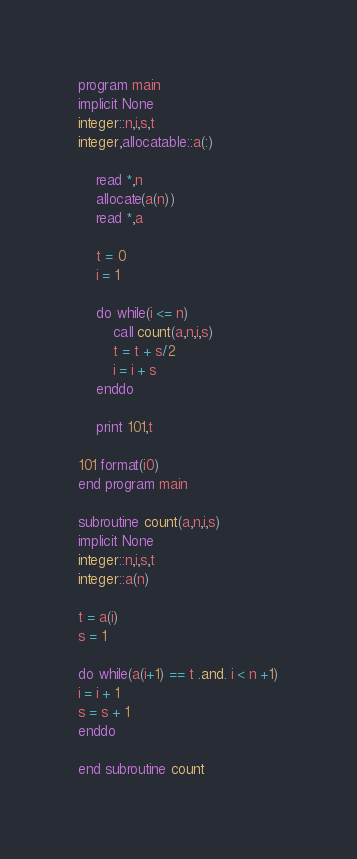<code> <loc_0><loc_0><loc_500><loc_500><_FORTRAN_>program main
implicit None
integer::n,i,s,t
integer,allocatable::a(:)

	read *,n
	allocate(a(n))
	read *,a
	
	t = 0
	i = 1
	
	do while(i <= n)
		call count(a,n,i,s)
		t = t + s/2
		i = i + s
	enddo
	
	print 101,t
	
101 format(i0)
end program main

subroutine count(a,n,i,s)
implicit None
integer::n,i,s,t
integer::a(n)

t = a(i)
s = 1

do while(a(i+1) == t .and. i < n +1)
i = i + 1
s = s + 1
enddo

end subroutine count</code> 